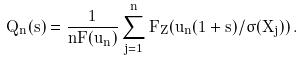<formula> <loc_0><loc_0><loc_500><loc_500>Q _ { n } ( s ) = \frac { 1 } { n \bar { F } ( u _ { n } ) } \sum _ { j = 1 } ^ { n } \bar { F } _ { Z } ( u _ { n } ( 1 + s ) / \sigma ( X _ { j } ) ) \, .</formula> 